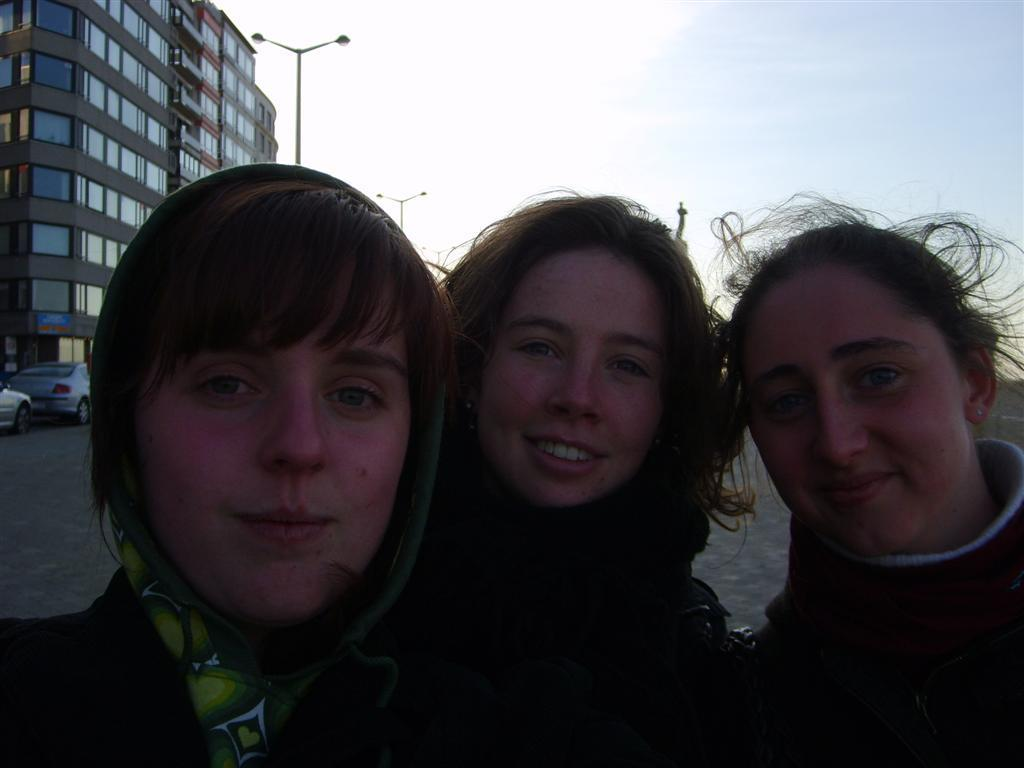How many people are in the image? There are three ladies in the image. What can be seen in the background of the image? There is a building, vehicles, street light poles, and the sky visible in the background of the image. What type of suit is the owl wearing in the image? There is no owl present in the image, and therefore no suit can be observed. Is there any indication of a battle taking place in the image? There is no indication of a battle or any conflict in the image. 